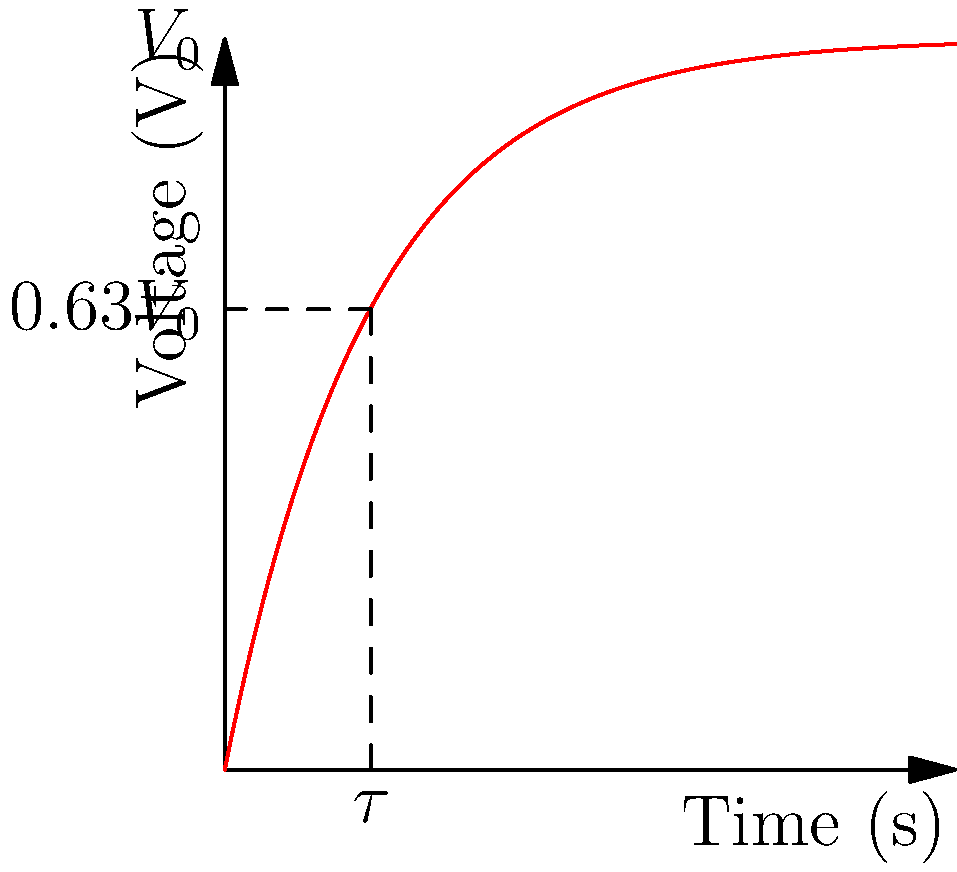In the RC circuit shown, a capacitor is being charged through a resistor. The voltage across the capacitor is plotted over time. If the time constant $\tau = RC = 1$ second and the supply voltage $V_0 = 5$ volts, what is the voltage across the capacitor at $t = 2$ seconds? To solve this problem, we'll follow these steps:

1) The equation for the voltage across a charging capacitor in an RC circuit is:

   $$V(t) = V_0(1 - e^{-t/\tau})$$

   where $V_0$ is the supply voltage, $t$ is time, and $\tau$ is the time constant.

2) We're given:
   - $V_0 = 5$ volts
   - $\tau = 1$ second
   - $t = 2$ seconds

3) Let's substitute these values into our equation:

   $$V(2) = 5(1 - e^{-2/1})$$

4) Simplify:
   $$V(2) = 5(1 - e^{-2})$$

5) Calculate $e^{-2}$:
   $$e^{-2} \approx 0.1353$$

6) Substitute this value:
   $$V(2) = 5(1 - 0.1353) = 5(0.8647)$$

7) Compute the final result:
   $$V(2) = 4.3235\text{ volts}$$

Thus, after 2 seconds, the voltage across the capacitor will be approximately 4.32 volts.
Answer: $4.32$ volts 